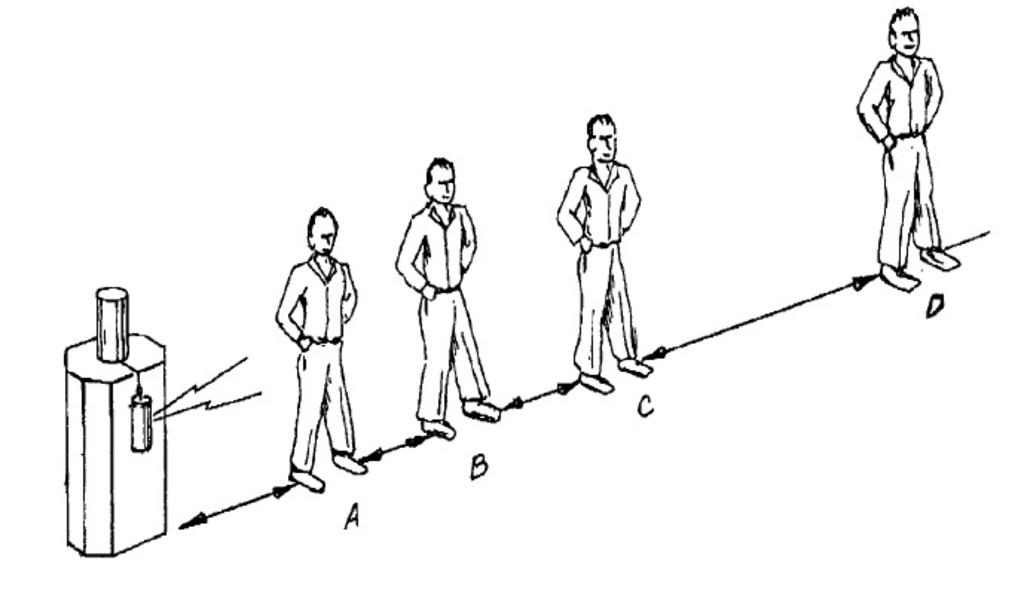What is the main subject in the center of the image? There are depictions of persons in the center of the image. Can you tell me how many rabbits are playing on the playground in the image? There are no rabbits or playground present in the image; it features depictions of persons. What type of friction can be observed between the persons in the image? There is no friction observable between the persons in the image, as it is a static depiction. 